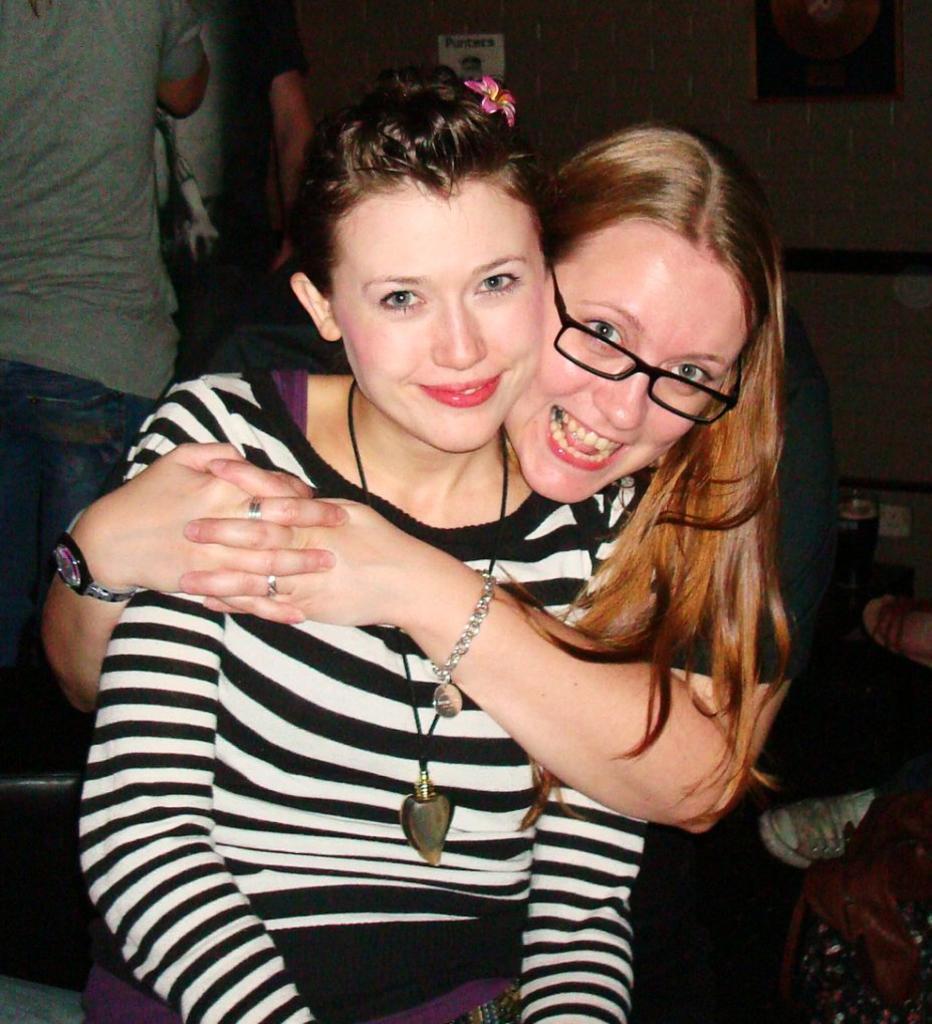Can you describe this image briefly? Here we can see a woman is sitting on a platform and there is an other woman holding this woman with her hands and smiling. In the background there are few persons,glass on a platform and on the right we can see persons legs and there is a frame and an object on the wall. 